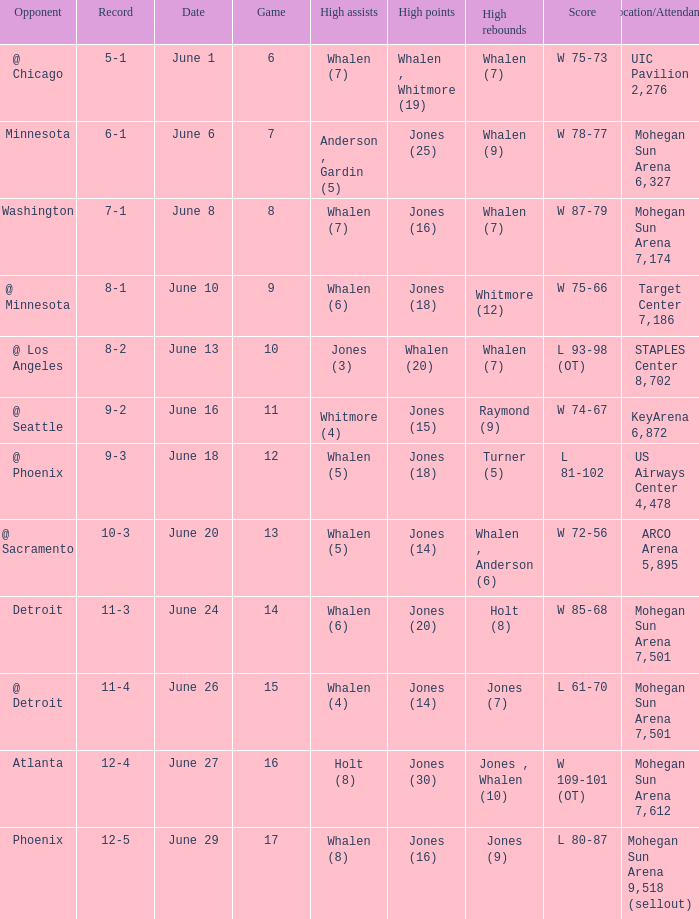Help me parse the entirety of this table. {'header': ['Opponent', 'Record', 'Date', 'Game', 'High assists', 'High points', 'High rebounds', 'Score', 'Location/Attendance'], 'rows': [['@ Chicago', '5-1', 'June 1', '6', 'Whalen (7)', 'Whalen , Whitmore (19)', 'Whalen (7)', 'W 75-73', 'UIC Pavilion 2,276'], ['Minnesota', '6-1', 'June 6', '7', 'Anderson , Gardin (5)', 'Jones (25)', 'Whalen (9)', 'W 78-77', 'Mohegan Sun Arena 6,327'], ['Washington', '7-1', 'June 8', '8', 'Whalen (7)', 'Jones (16)', 'Whalen (7)', 'W 87-79', 'Mohegan Sun Arena 7,174'], ['@ Minnesota', '8-1', 'June 10', '9', 'Whalen (6)', 'Jones (18)', 'Whitmore (12)', 'W 75-66', 'Target Center 7,186'], ['@ Los Angeles', '8-2', 'June 13', '10', 'Jones (3)', 'Whalen (20)', 'Whalen (7)', 'L 93-98 (OT)', 'STAPLES Center 8,702'], ['@ Seattle', '9-2', 'June 16', '11', 'Whitmore (4)', 'Jones (15)', 'Raymond (9)', 'W 74-67', 'KeyArena 6,872'], ['@ Phoenix', '9-3', 'June 18', '12', 'Whalen (5)', 'Jones (18)', 'Turner (5)', 'L 81-102', 'US Airways Center 4,478'], ['@ Sacramento', '10-3', 'June 20', '13', 'Whalen (5)', 'Jones (14)', 'Whalen , Anderson (6)', 'W 72-56', 'ARCO Arena 5,895'], ['Detroit', '11-3', 'June 24', '14', 'Whalen (6)', 'Jones (20)', 'Holt (8)', 'W 85-68', 'Mohegan Sun Arena 7,501'], ['@ Detroit', '11-4', 'June 26', '15', 'Whalen (4)', 'Jones (14)', 'Jones (7)', 'L 61-70', 'Mohegan Sun Arena 7,501'], ['Atlanta', '12-4', 'June 27', '16', 'Holt (8)', 'Jones (30)', 'Jones , Whalen (10)', 'W 109-101 (OT)', 'Mohegan Sun Arena 7,612'], ['Phoenix', '12-5', 'June 29', '17', 'Whalen (8)', 'Jones (16)', 'Jones (9)', 'L 80-87', 'Mohegan Sun Arena 9,518 (sellout)']]} Who had the high assists when the game was less than 13 and the score was w 75-66? Whalen (6). 